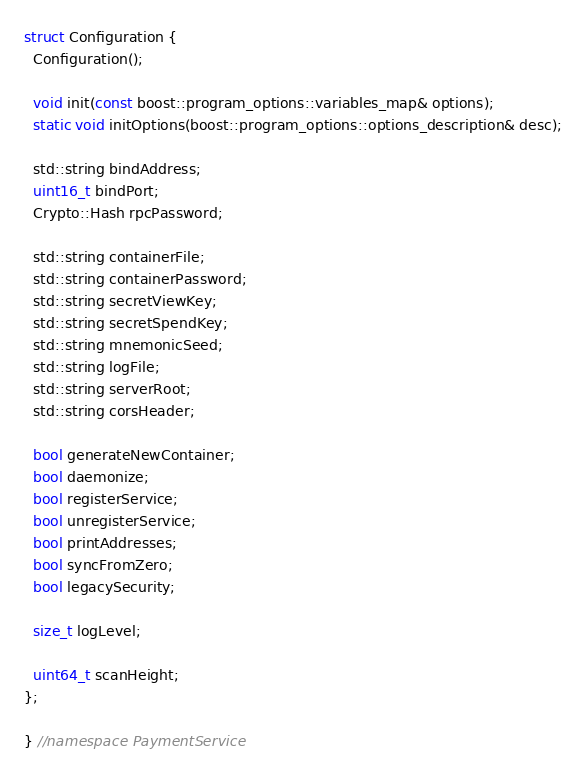<code> <loc_0><loc_0><loc_500><loc_500><_C_>
struct Configuration {
  Configuration();

  void init(const boost::program_options::variables_map& options);
  static void initOptions(boost::program_options::options_description& desc);

  std::string bindAddress;
  uint16_t bindPort;
  Crypto::Hash rpcPassword;

  std::string containerFile;
  std::string containerPassword;
  std::string secretViewKey;
  std::string secretSpendKey;
  std::string mnemonicSeed;
  std::string logFile;
  std::string serverRoot;
  std::string corsHeader;

  bool generateNewContainer;
  bool daemonize;
  bool registerService;
  bool unregisterService;
  bool printAddresses;
  bool syncFromZero;
  bool legacySecurity;

  size_t logLevel;

  uint64_t scanHeight;
};

} //namespace PaymentService
</code> 